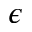Convert formula to latex. <formula><loc_0><loc_0><loc_500><loc_500>\epsilon</formula> 